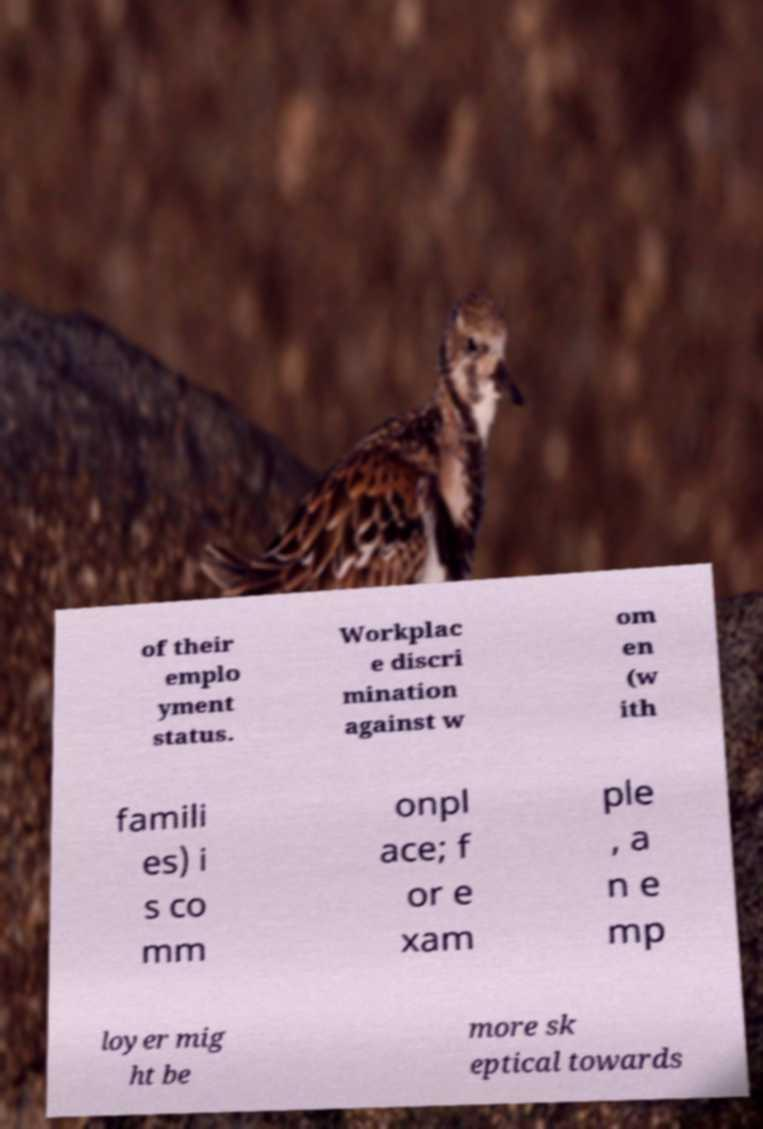Could you extract and type out the text from this image? of their emplo yment status. Workplac e discri mination against w om en (w ith famili es) i s co mm onpl ace; f or e xam ple , a n e mp loyer mig ht be more sk eptical towards 